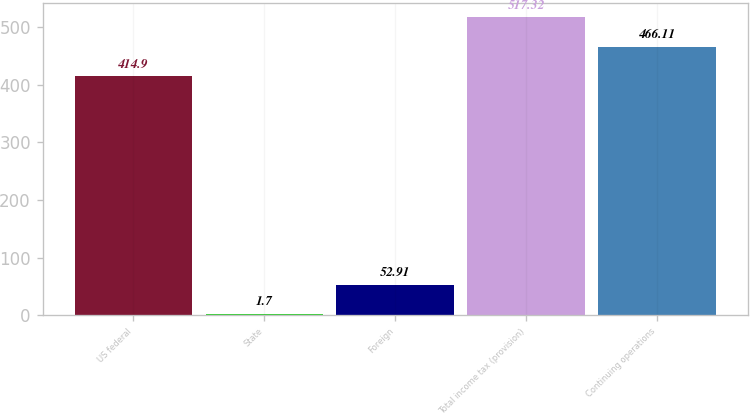Convert chart to OTSL. <chart><loc_0><loc_0><loc_500><loc_500><bar_chart><fcel>US federal<fcel>State<fcel>Foreign<fcel>Total income tax (provision)<fcel>Continuing operations<nl><fcel>414.9<fcel>1.7<fcel>52.91<fcel>517.32<fcel>466.11<nl></chart> 